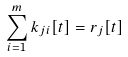Convert formula to latex. <formula><loc_0><loc_0><loc_500><loc_500>\sum _ { i = 1 } ^ { m } k _ { j i } [ t ] = r _ { j } [ t ]</formula> 